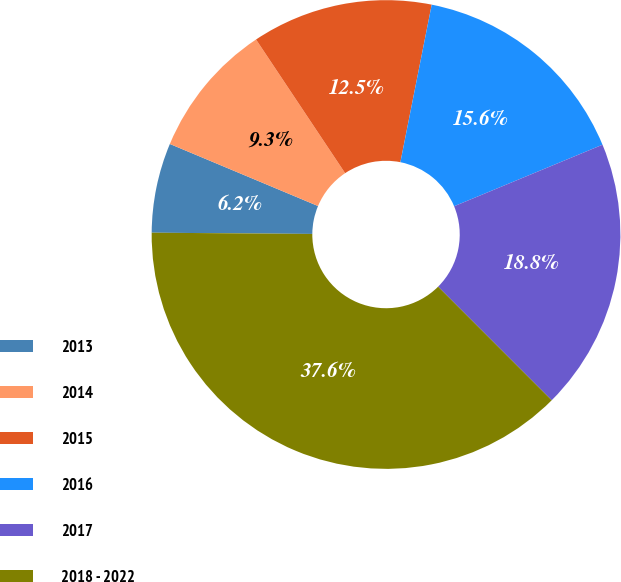Convert chart. <chart><loc_0><loc_0><loc_500><loc_500><pie_chart><fcel>2013<fcel>2014<fcel>2015<fcel>2016<fcel>2017<fcel>2018 - 2022<nl><fcel>6.19%<fcel>9.33%<fcel>12.48%<fcel>15.62%<fcel>18.76%<fcel>37.62%<nl></chart> 